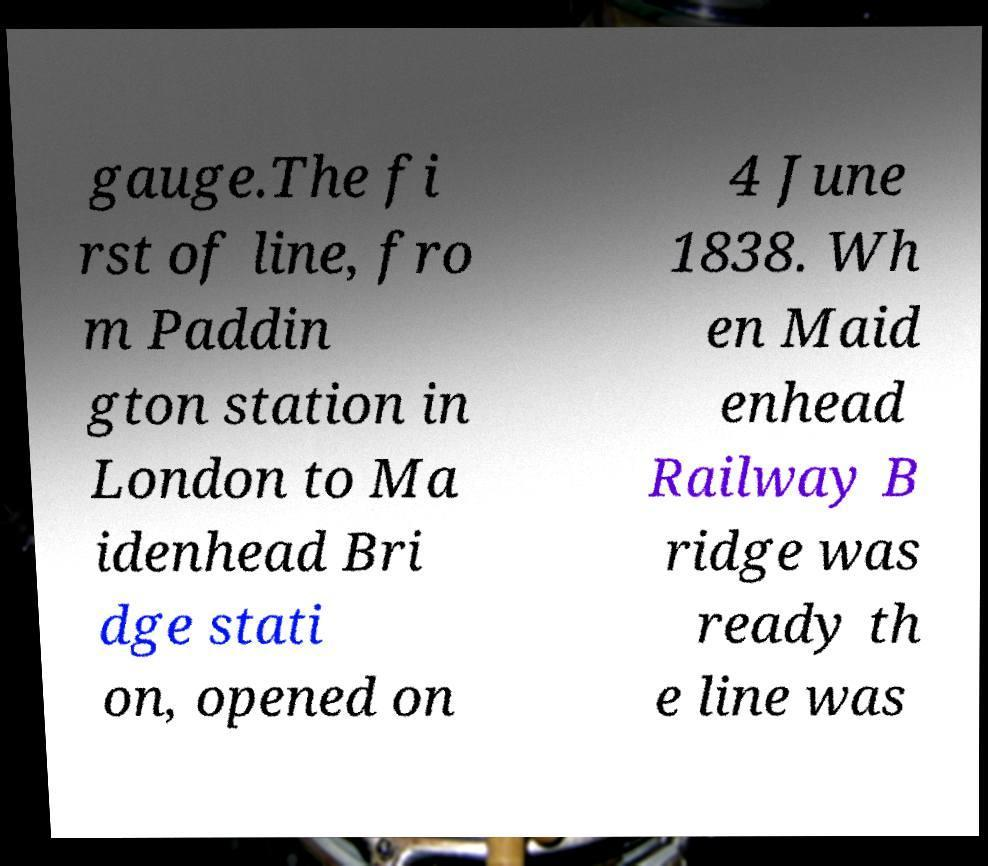Can you accurately transcribe the text from the provided image for me? gauge.The fi rst of line, fro m Paddin gton station in London to Ma idenhead Bri dge stati on, opened on 4 June 1838. Wh en Maid enhead Railway B ridge was ready th e line was 